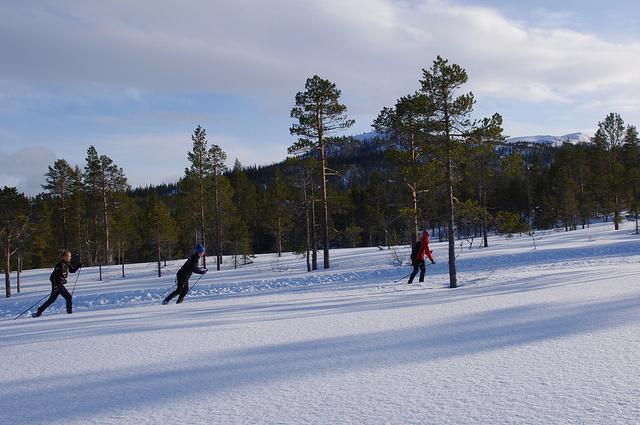What makes the ripples in the snow?
Concise answer only. Wind. What is the man on the far left holding?
Keep it brief. Ski poles. Is this a warm or a cold day?
Short answer required. Cold. 